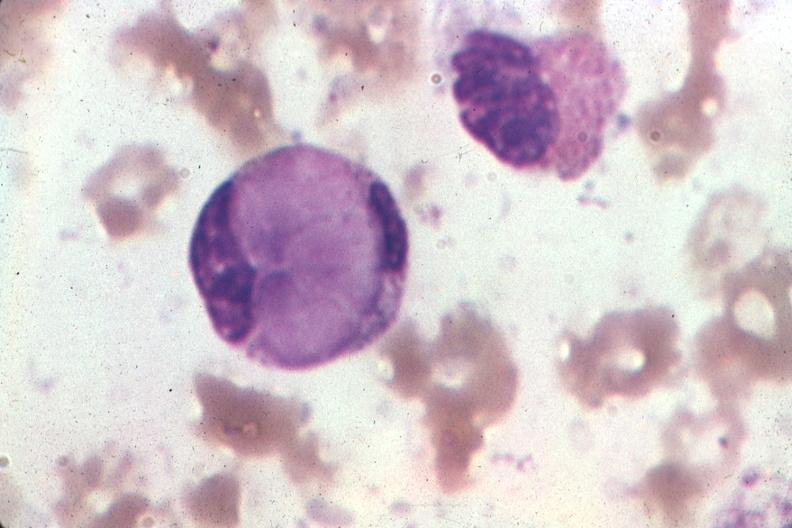s bone marrow present?
Answer the question using a single word or phrase. Yes 